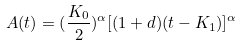Convert formula to latex. <formula><loc_0><loc_0><loc_500><loc_500>A ( t ) = ( \frac { K _ { 0 } } { 2 } ) ^ { \alpha } [ ( 1 + d ) ( t - K _ { 1 } ) ] ^ { \alpha }</formula> 